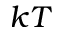<formula> <loc_0><loc_0><loc_500><loc_500>k T</formula> 